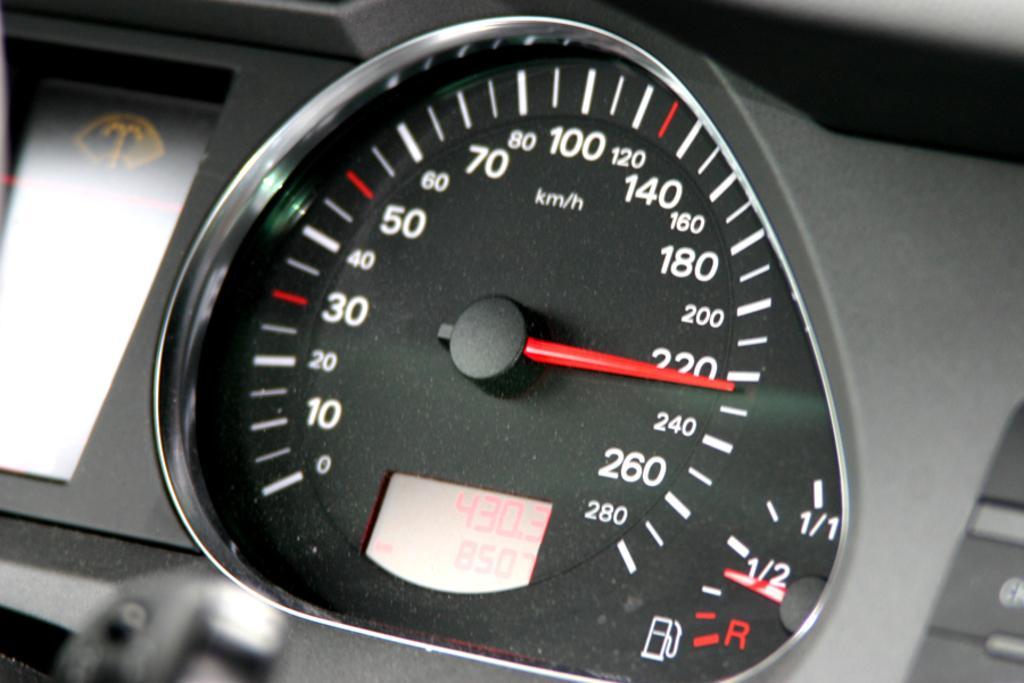Can you describe this image briefly? In this image there is a display meter of a vehicle. There are numbers and alphabets on the display meter. 